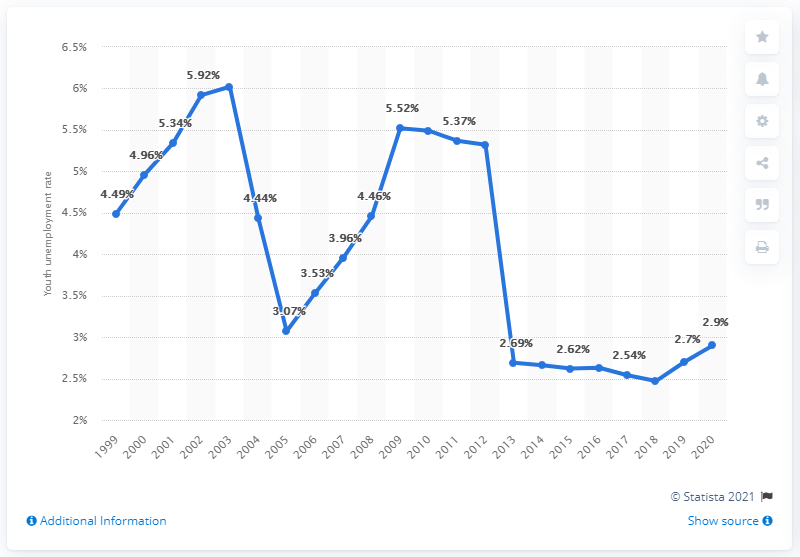Point out several critical features in this image. In 2020, the youth unemployment rate in Uganda was 2.9%. The youth unemployment rate ranged from 3.42% in 1999 to 3.42% in 2020, with no distinct difference between the highest and lowest values during this time period. The youth unemployment rate in 2020 is 2.9%. 